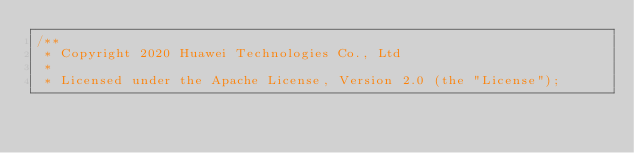<code> <loc_0><loc_0><loc_500><loc_500><_Cuda_>/**
 * Copyright 2020 Huawei Technologies Co., Ltd
 *
 * Licensed under the Apache License, Version 2.0 (the "License");</code> 